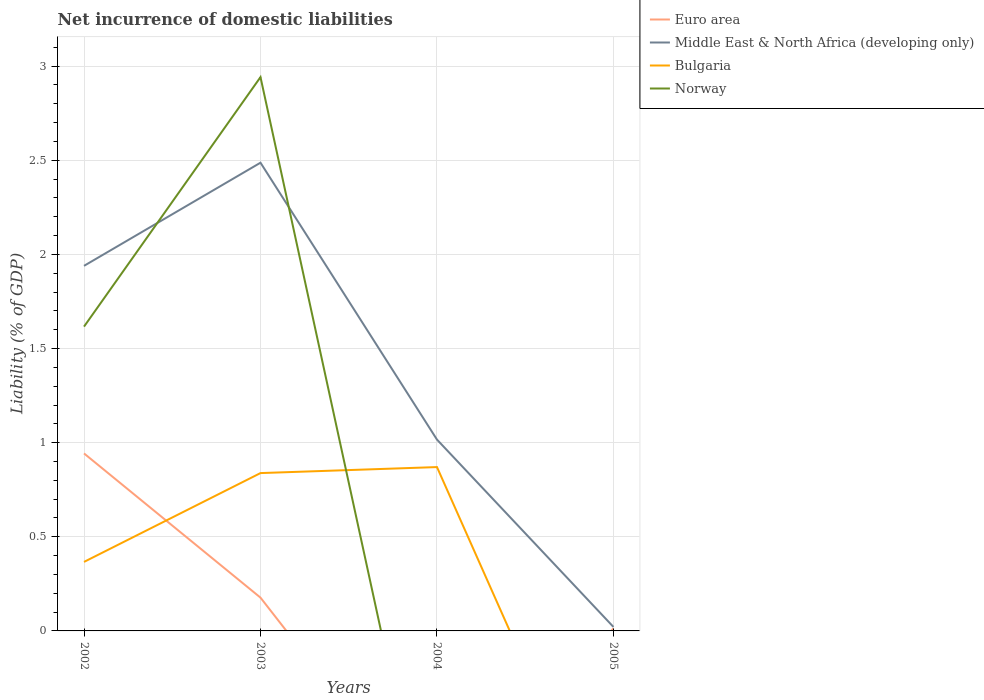How many different coloured lines are there?
Offer a terse response. 4. Across all years, what is the maximum net incurrence of domestic liabilities in Middle East & North Africa (developing only)?
Keep it short and to the point. 0.02. What is the total net incurrence of domestic liabilities in Middle East & North Africa (developing only) in the graph?
Offer a terse response. 0.92. What is the difference between the highest and the second highest net incurrence of domestic liabilities in Bulgaria?
Offer a very short reply. 0.87. How many lines are there?
Your answer should be very brief. 4. What is the difference between two consecutive major ticks on the Y-axis?
Keep it short and to the point. 0.5. Are the values on the major ticks of Y-axis written in scientific E-notation?
Give a very brief answer. No. Does the graph contain any zero values?
Offer a very short reply. Yes. Does the graph contain grids?
Your response must be concise. Yes. Where does the legend appear in the graph?
Provide a succinct answer. Top right. How are the legend labels stacked?
Offer a very short reply. Vertical. What is the title of the graph?
Provide a succinct answer. Net incurrence of domestic liabilities. Does "North America" appear as one of the legend labels in the graph?
Provide a succinct answer. No. What is the label or title of the Y-axis?
Ensure brevity in your answer.  Liability (% of GDP). What is the Liability (% of GDP) in Euro area in 2002?
Keep it short and to the point. 0.94. What is the Liability (% of GDP) in Middle East & North Africa (developing only) in 2002?
Your answer should be very brief. 1.94. What is the Liability (% of GDP) in Bulgaria in 2002?
Your answer should be very brief. 0.37. What is the Liability (% of GDP) in Norway in 2002?
Keep it short and to the point. 1.62. What is the Liability (% of GDP) in Euro area in 2003?
Make the answer very short. 0.18. What is the Liability (% of GDP) of Middle East & North Africa (developing only) in 2003?
Ensure brevity in your answer.  2.49. What is the Liability (% of GDP) in Bulgaria in 2003?
Offer a very short reply. 0.84. What is the Liability (% of GDP) in Norway in 2003?
Provide a succinct answer. 2.94. What is the Liability (% of GDP) in Middle East & North Africa (developing only) in 2004?
Offer a terse response. 1.02. What is the Liability (% of GDP) of Bulgaria in 2004?
Offer a terse response. 0.87. What is the Liability (% of GDP) of Euro area in 2005?
Keep it short and to the point. 0.01. What is the Liability (% of GDP) of Middle East & North Africa (developing only) in 2005?
Give a very brief answer. 0.02. What is the Liability (% of GDP) of Norway in 2005?
Your answer should be compact. 0. Across all years, what is the maximum Liability (% of GDP) in Euro area?
Offer a terse response. 0.94. Across all years, what is the maximum Liability (% of GDP) in Middle East & North Africa (developing only)?
Your response must be concise. 2.49. Across all years, what is the maximum Liability (% of GDP) in Bulgaria?
Ensure brevity in your answer.  0.87. Across all years, what is the maximum Liability (% of GDP) of Norway?
Make the answer very short. 2.94. Across all years, what is the minimum Liability (% of GDP) of Euro area?
Your answer should be very brief. 0. Across all years, what is the minimum Liability (% of GDP) of Middle East & North Africa (developing only)?
Your answer should be compact. 0.02. What is the total Liability (% of GDP) of Euro area in the graph?
Keep it short and to the point. 1.13. What is the total Liability (% of GDP) of Middle East & North Africa (developing only) in the graph?
Give a very brief answer. 5.46. What is the total Liability (% of GDP) in Bulgaria in the graph?
Offer a terse response. 2.08. What is the total Liability (% of GDP) in Norway in the graph?
Your answer should be very brief. 4.56. What is the difference between the Liability (% of GDP) of Euro area in 2002 and that in 2003?
Provide a short and direct response. 0.77. What is the difference between the Liability (% of GDP) of Middle East & North Africa (developing only) in 2002 and that in 2003?
Make the answer very short. -0.55. What is the difference between the Liability (% of GDP) in Bulgaria in 2002 and that in 2003?
Make the answer very short. -0.47. What is the difference between the Liability (% of GDP) in Norway in 2002 and that in 2003?
Your response must be concise. -1.33. What is the difference between the Liability (% of GDP) in Middle East & North Africa (developing only) in 2002 and that in 2004?
Provide a succinct answer. 0.92. What is the difference between the Liability (% of GDP) in Bulgaria in 2002 and that in 2004?
Give a very brief answer. -0.5. What is the difference between the Liability (% of GDP) in Euro area in 2002 and that in 2005?
Offer a very short reply. 0.93. What is the difference between the Liability (% of GDP) of Middle East & North Africa (developing only) in 2002 and that in 2005?
Your answer should be very brief. 1.92. What is the difference between the Liability (% of GDP) in Middle East & North Africa (developing only) in 2003 and that in 2004?
Keep it short and to the point. 1.47. What is the difference between the Liability (% of GDP) in Bulgaria in 2003 and that in 2004?
Offer a terse response. -0.03. What is the difference between the Liability (% of GDP) in Euro area in 2003 and that in 2005?
Your answer should be very brief. 0.16. What is the difference between the Liability (% of GDP) of Middle East & North Africa (developing only) in 2003 and that in 2005?
Make the answer very short. 2.47. What is the difference between the Liability (% of GDP) in Middle East & North Africa (developing only) in 2004 and that in 2005?
Your response must be concise. 1. What is the difference between the Liability (% of GDP) in Euro area in 2002 and the Liability (% of GDP) in Middle East & North Africa (developing only) in 2003?
Provide a short and direct response. -1.54. What is the difference between the Liability (% of GDP) in Euro area in 2002 and the Liability (% of GDP) in Bulgaria in 2003?
Ensure brevity in your answer.  0.1. What is the difference between the Liability (% of GDP) in Euro area in 2002 and the Liability (% of GDP) in Norway in 2003?
Provide a short and direct response. -2. What is the difference between the Liability (% of GDP) in Middle East & North Africa (developing only) in 2002 and the Liability (% of GDP) in Bulgaria in 2003?
Your answer should be very brief. 1.1. What is the difference between the Liability (% of GDP) in Middle East & North Africa (developing only) in 2002 and the Liability (% of GDP) in Norway in 2003?
Offer a terse response. -1. What is the difference between the Liability (% of GDP) in Bulgaria in 2002 and the Liability (% of GDP) in Norway in 2003?
Keep it short and to the point. -2.58. What is the difference between the Liability (% of GDP) of Euro area in 2002 and the Liability (% of GDP) of Middle East & North Africa (developing only) in 2004?
Provide a short and direct response. -0.07. What is the difference between the Liability (% of GDP) in Euro area in 2002 and the Liability (% of GDP) in Bulgaria in 2004?
Your response must be concise. 0.07. What is the difference between the Liability (% of GDP) in Middle East & North Africa (developing only) in 2002 and the Liability (% of GDP) in Bulgaria in 2004?
Offer a terse response. 1.07. What is the difference between the Liability (% of GDP) of Euro area in 2002 and the Liability (% of GDP) of Middle East & North Africa (developing only) in 2005?
Provide a short and direct response. 0.92. What is the difference between the Liability (% of GDP) in Euro area in 2003 and the Liability (% of GDP) in Middle East & North Africa (developing only) in 2004?
Provide a short and direct response. -0.84. What is the difference between the Liability (% of GDP) of Euro area in 2003 and the Liability (% of GDP) of Bulgaria in 2004?
Offer a terse response. -0.69. What is the difference between the Liability (% of GDP) in Middle East & North Africa (developing only) in 2003 and the Liability (% of GDP) in Bulgaria in 2004?
Your response must be concise. 1.62. What is the difference between the Liability (% of GDP) in Euro area in 2003 and the Liability (% of GDP) in Middle East & North Africa (developing only) in 2005?
Your response must be concise. 0.16. What is the average Liability (% of GDP) of Euro area per year?
Make the answer very short. 0.28. What is the average Liability (% of GDP) in Middle East & North Africa (developing only) per year?
Offer a terse response. 1.37. What is the average Liability (% of GDP) of Bulgaria per year?
Your answer should be very brief. 0.52. What is the average Liability (% of GDP) in Norway per year?
Your answer should be very brief. 1.14. In the year 2002, what is the difference between the Liability (% of GDP) of Euro area and Liability (% of GDP) of Middle East & North Africa (developing only)?
Give a very brief answer. -1. In the year 2002, what is the difference between the Liability (% of GDP) in Euro area and Liability (% of GDP) in Bulgaria?
Provide a short and direct response. 0.58. In the year 2002, what is the difference between the Liability (% of GDP) in Euro area and Liability (% of GDP) in Norway?
Your answer should be compact. -0.67. In the year 2002, what is the difference between the Liability (% of GDP) of Middle East & North Africa (developing only) and Liability (% of GDP) of Bulgaria?
Your answer should be very brief. 1.57. In the year 2002, what is the difference between the Liability (% of GDP) of Middle East & North Africa (developing only) and Liability (% of GDP) of Norway?
Your answer should be very brief. 0.32. In the year 2002, what is the difference between the Liability (% of GDP) in Bulgaria and Liability (% of GDP) in Norway?
Your response must be concise. -1.25. In the year 2003, what is the difference between the Liability (% of GDP) in Euro area and Liability (% of GDP) in Middle East & North Africa (developing only)?
Offer a terse response. -2.31. In the year 2003, what is the difference between the Liability (% of GDP) in Euro area and Liability (% of GDP) in Bulgaria?
Your answer should be compact. -0.66. In the year 2003, what is the difference between the Liability (% of GDP) in Euro area and Liability (% of GDP) in Norway?
Give a very brief answer. -2.76. In the year 2003, what is the difference between the Liability (% of GDP) in Middle East & North Africa (developing only) and Liability (% of GDP) in Bulgaria?
Provide a short and direct response. 1.65. In the year 2003, what is the difference between the Liability (% of GDP) of Middle East & North Africa (developing only) and Liability (% of GDP) of Norway?
Keep it short and to the point. -0.45. In the year 2003, what is the difference between the Liability (% of GDP) in Bulgaria and Liability (% of GDP) in Norway?
Offer a very short reply. -2.1. In the year 2004, what is the difference between the Liability (% of GDP) in Middle East & North Africa (developing only) and Liability (% of GDP) in Bulgaria?
Provide a succinct answer. 0.15. In the year 2005, what is the difference between the Liability (% of GDP) in Euro area and Liability (% of GDP) in Middle East & North Africa (developing only)?
Your answer should be compact. -0.01. What is the ratio of the Liability (% of GDP) in Euro area in 2002 to that in 2003?
Your answer should be compact. 5.33. What is the ratio of the Liability (% of GDP) of Middle East & North Africa (developing only) in 2002 to that in 2003?
Your answer should be very brief. 0.78. What is the ratio of the Liability (% of GDP) in Bulgaria in 2002 to that in 2003?
Your answer should be compact. 0.44. What is the ratio of the Liability (% of GDP) in Norway in 2002 to that in 2003?
Make the answer very short. 0.55. What is the ratio of the Liability (% of GDP) of Middle East & North Africa (developing only) in 2002 to that in 2004?
Your answer should be compact. 1.91. What is the ratio of the Liability (% of GDP) in Bulgaria in 2002 to that in 2004?
Your answer should be very brief. 0.42. What is the ratio of the Liability (% of GDP) of Euro area in 2002 to that in 2005?
Make the answer very short. 70.45. What is the ratio of the Liability (% of GDP) of Middle East & North Africa (developing only) in 2002 to that in 2005?
Make the answer very short. 91.33. What is the ratio of the Liability (% of GDP) in Middle East & North Africa (developing only) in 2003 to that in 2004?
Your answer should be very brief. 2.45. What is the ratio of the Liability (% of GDP) in Bulgaria in 2003 to that in 2004?
Give a very brief answer. 0.96. What is the ratio of the Liability (% of GDP) of Euro area in 2003 to that in 2005?
Ensure brevity in your answer.  13.21. What is the ratio of the Liability (% of GDP) of Middle East & North Africa (developing only) in 2003 to that in 2005?
Offer a very short reply. 117.13. What is the ratio of the Liability (% of GDP) of Middle East & North Africa (developing only) in 2004 to that in 2005?
Give a very brief answer. 47.86. What is the difference between the highest and the second highest Liability (% of GDP) in Euro area?
Your answer should be compact. 0.77. What is the difference between the highest and the second highest Liability (% of GDP) of Middle East & North Africa (developing only)?
Ensure brevity in your answer.  0.55. What is the difference between the highest and the second highest Liability (% of GDP) of Bulgaria?
Offer a terse response. 0.03. What is the difference between the highest and the lowest Liability (% of GDP) in Euro area?
Your answer should be compact. 0.94. What is the difference between the highest and the lowest Liability (% of GDP) of Middle East & North Africa (developing only)?
Your response must be concise. 2.47. What is the difference between the highest and the lowest Liability (% of GDP) in Bulgaria?
Make the answer very short. 0.87. What is the difference between the highest and the lowest Liability (% of GDP) in Norway?
Offer a terse response. 2.94. 